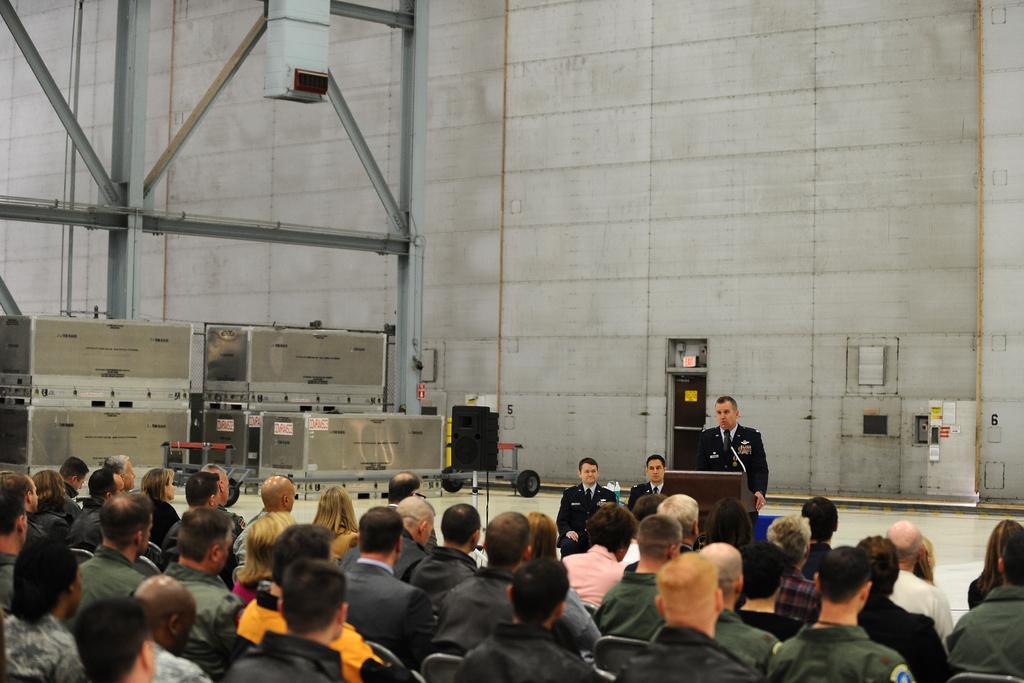Describe this image in one or two sentences. At the bottom of the image we can see people sitting. In the center there is a man standing, before him there is a podium and we can see a mic placed on the podium. In the background there is a wall. On the left there is an equipment. 